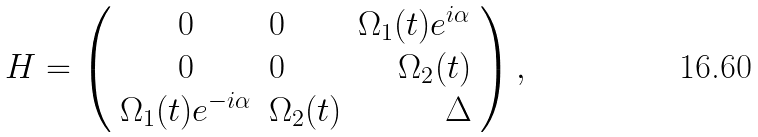<formula> <loc_0><loc_0><loc_500><loc_500>H = \left ( \begin{array} { c l r r } 0 & 0 & \Omega _ { 1 } ( t ) e ^ { i \alpha } \\ 0 & 0 & \Omega _ { 2 } ( t ) \\ \Omega _ { 1 } ( t ) e ^ { - i \alpha } & \Omega _ { 2 } ( t ) & \Delta \end{array} \right ) ,</formula> 